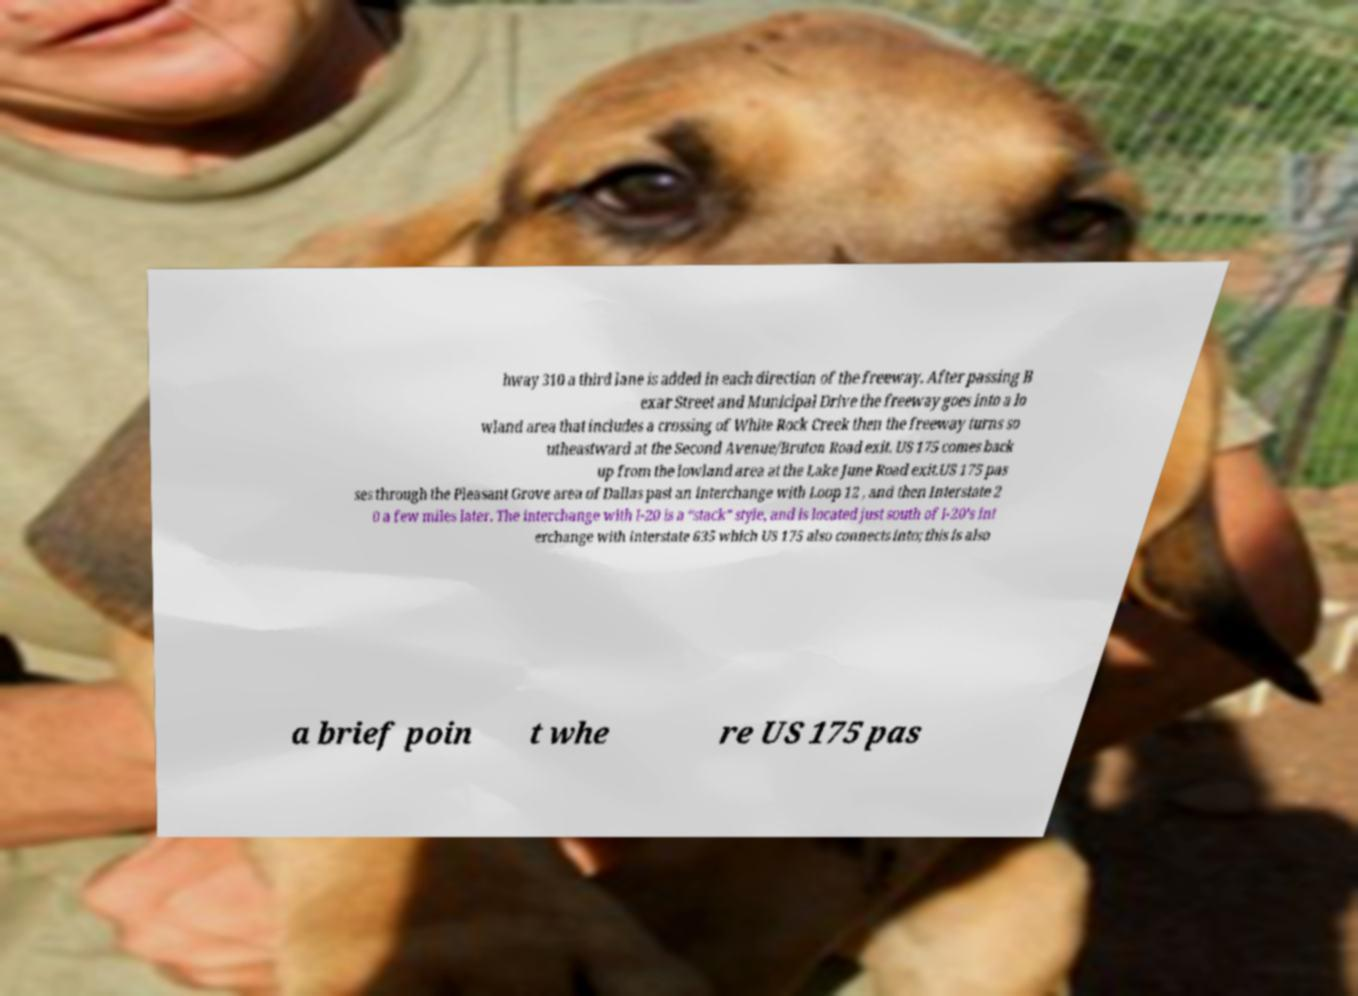For documentation purposes, I need the text within this image transcribed. Could you provide that? hway 310 a third lane is added in each direction of the freeway. After passing B exar Street and Municipal Drive the freeway goes into a lo wland area that includes a crossing of White Rock Creek then the freeway turns so utheastward at the Second Avenue/Bruton Road exit. US 175 comes back up from the lowland area at the Lake June Road exit.US 175 pas ses through the Pleasant Grove area of Dallas past an interchange with Loop 12 , and then Interstate 2 0 a few miles later. The interchange with I-20 is a “stack” style, and is located just south of I-20’s int erchange with Interstate 635 which US 175 also connects into; this is also a brief poin t whe re US 175 pas 